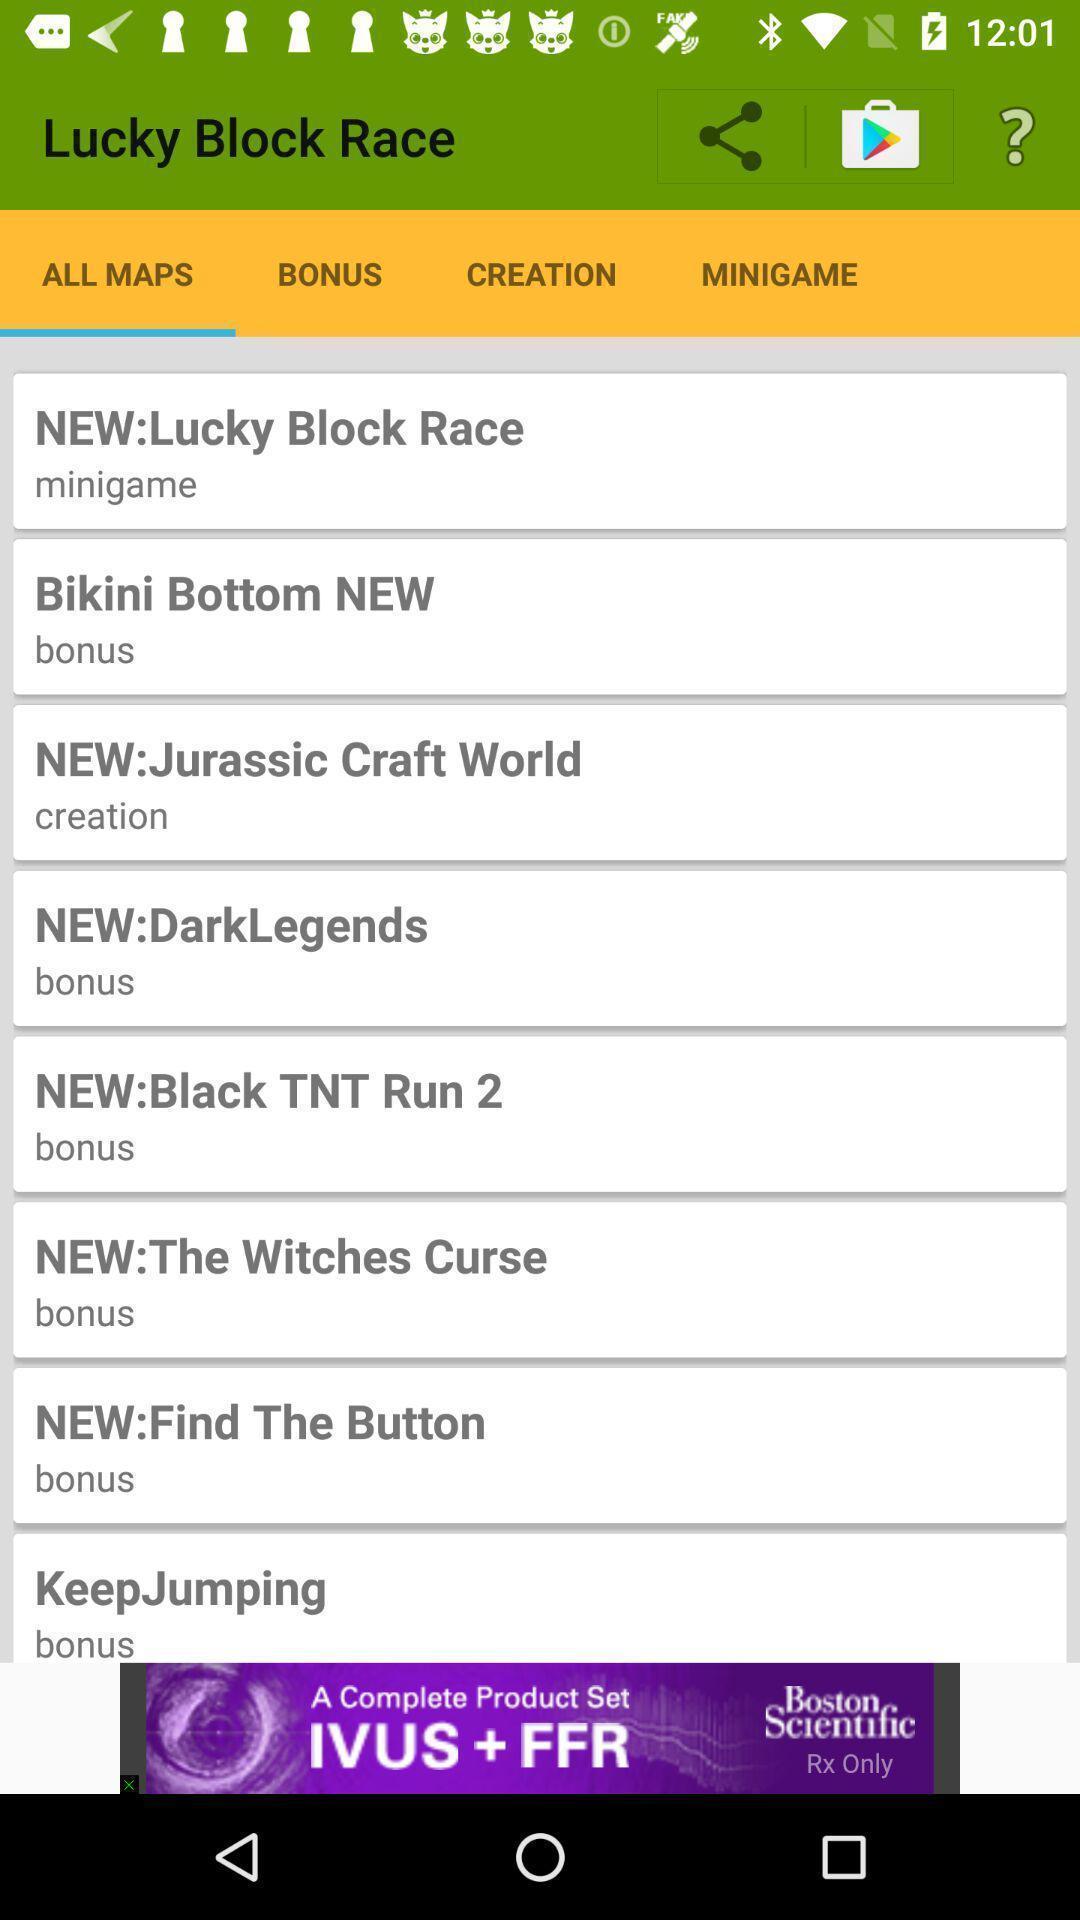What can you discern from this picture? Screen displaying the screen page. 